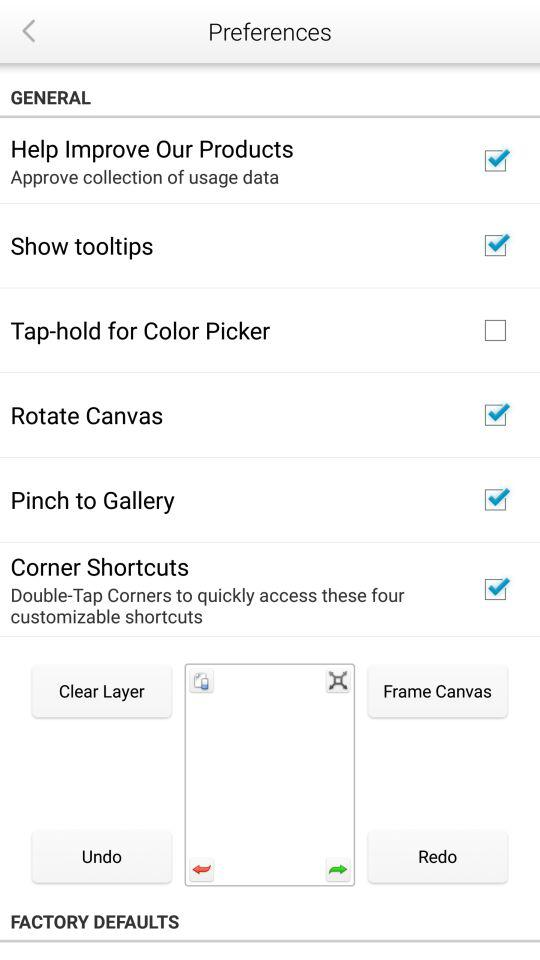Which option was selected? The selected options are "Help Improve Our Products", "Show tooltips", "Rotate Canvas", "Pinch to Gallery" and "Corner Shortcuts". 